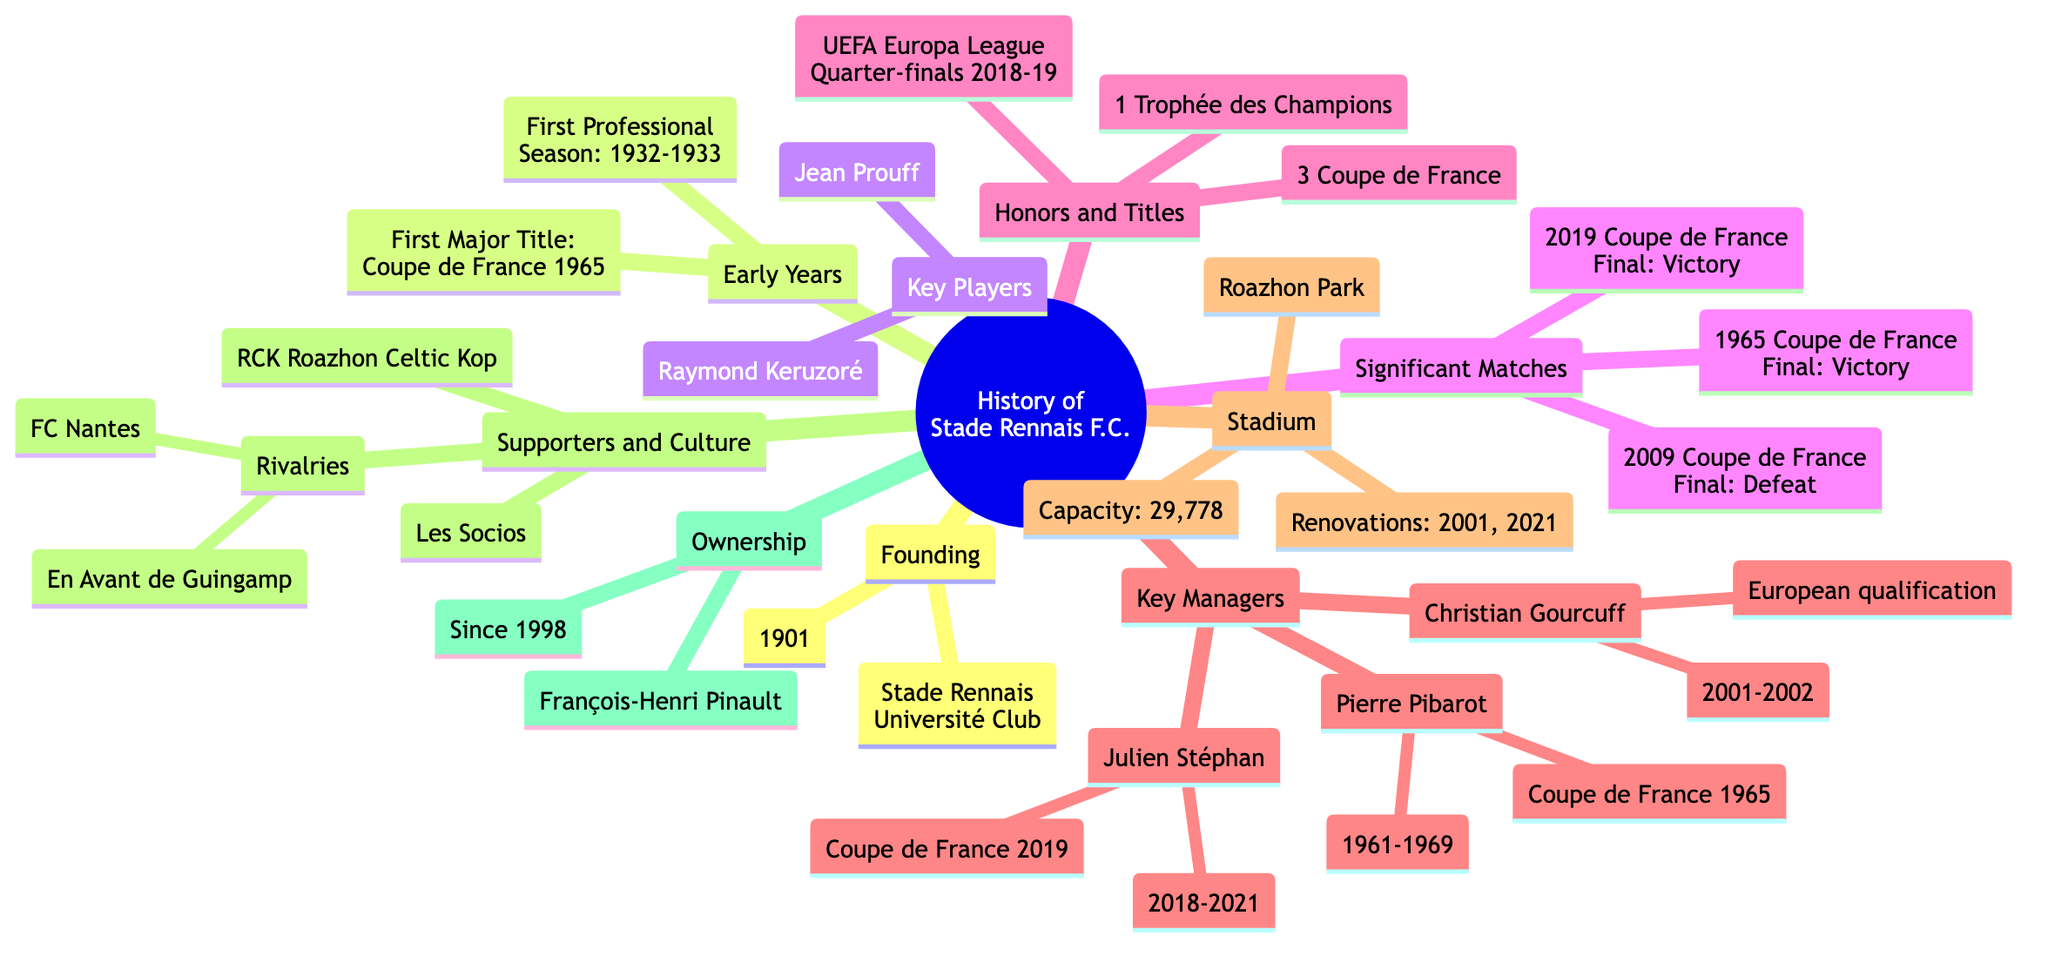What year was Stade Rennais F.C. founded? The founding year is explicitly stated in the "Founding" section of the diagram, listed as "1901."
Answer: 1901 Who was the iconic midfielder of the 1970s? In the "Key Players" section, it notes "Raymond Keruzoré" as an iconic midfielder, specifying the decade in which he played.
Answer: Raymond Keruzoré How many Coupe de France titles has Stade Rennais won? The "Honors and Titles" section provides the count of Coupe de France titles, which is stated as "3."
Answer: 3 What significant event occurred in the 2019 Coupe de France Final? The "Significant Matches" section mentions that Stade Rennais achieved "Victory over Paris Saint-Germain" in this final, indicating a positive outcome.
Answer: Victory over Paris Saint-Germain Who was the manager during the Coupe de France win in 1965? To find this, we refer to the "Key Managers" section where "Pierre Pibarot" is listed along with years of tenure that include "1961-1969," clearly indicating his involvement during the 1965 cup victory.
Answer: Pierre Pibarot What is the capacity of Roazhon Park? The "Stadium" section directly provides the capacity value, listed clearly as "29,778."
Answer: 29,778 Which supporter group is abbreviated as RCK? The "Supporters and Culture" section lists "RCK (Roazhon Celtic Kop)" as one of the supporter groups, giving the abbreviation along with its full name.
Answer: Roazhon Celtic Kop How many UEFA Europa League runs reached the Quarter-finals in 2018-19? Looking at the "Honors and Titles" section, it states the UEFA Europa League run reached the "Quarter-finals in 2018-19," providing a specific milestone.
Answer: Quarter-finals 2018-19 